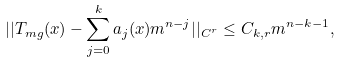<formula> <loc_0><loc_0><loc_500><loc_500>| | T _ { m g } ( x ) - \sum _ { j = 0 } ^ { k } a _ { j } ( x ) m ^ { n - j } | | _ { C ^ { r } } \leq C _ { k , r } m ^ { n - k - 1 } ,</formula> 